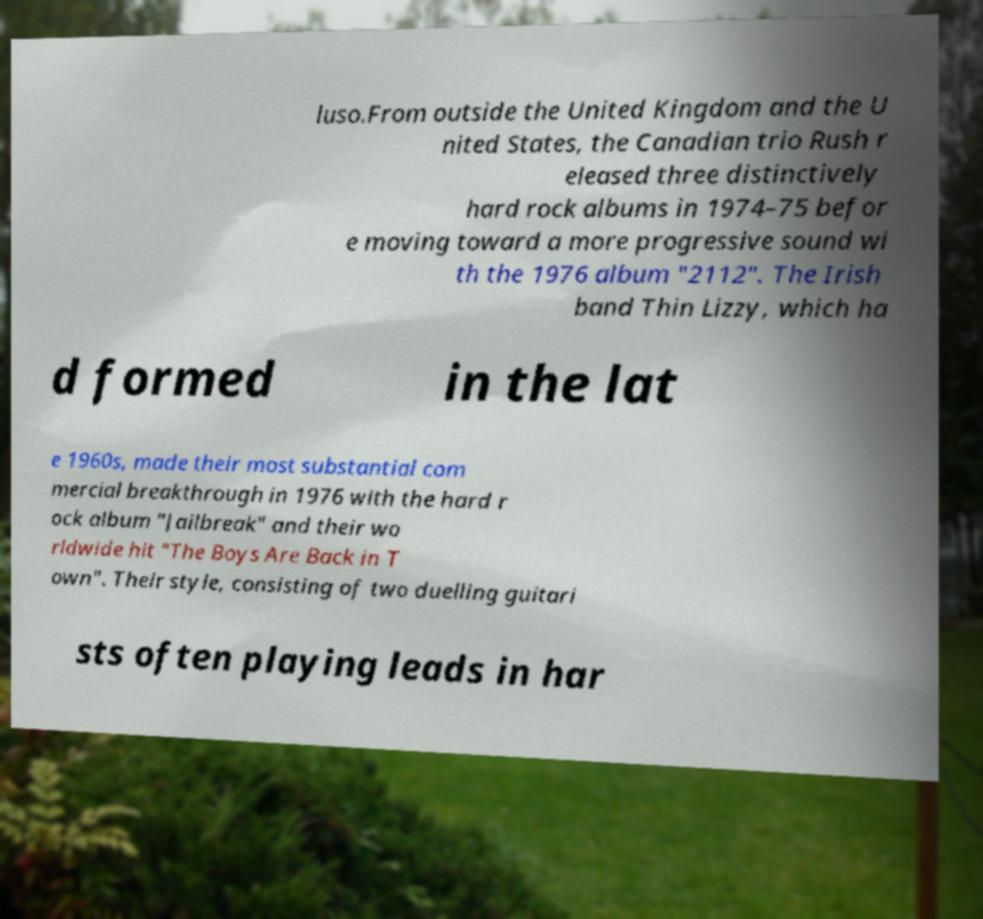Please identify and transcribe the text found in this image. luso.From outside the United Kingdom and the U nited States, the Canadian trio Rush r eleased three distinctively hard rock albums in 1974–75 befor e moving toward a more progressive sound wi th the 1976 album "2112". The Irish band Thin Lizzy, which ha d formed in the lat e 1960s, made their most substantial com mercial breakthrough in 1976 with the hard r ock album "Jailbreak" and their wo rldwide hit "The Boys Are Back in T own". Their style, consisting of two duelling guitari sts often playing leads in har 